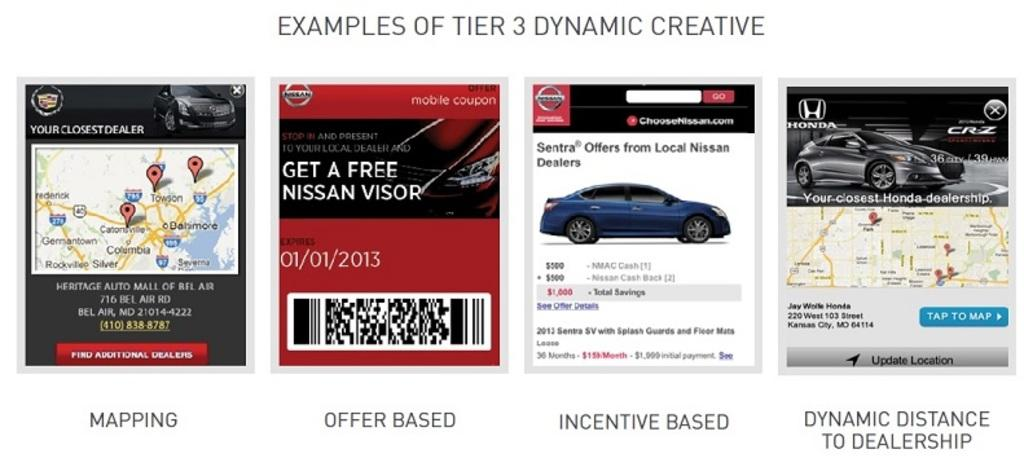What is the main subject of the image? The main subject of the image is a screenshot. What can be seen within the screenshot? The screenshot contains four images with cars and a bar code in the middle. Is there any additional information displayed in the screenshot? Yes, there is a map on the left side of the screenshot. How many cows can be seen grazing in the image? There are no cows present in the image; it features a screenshot with four images of cars, a bar code, and a map. What type of beetle is crawling on the map in the image? There are no beetles present in the image; it features a screenshot with four images of cars, a bar code, and a map. 